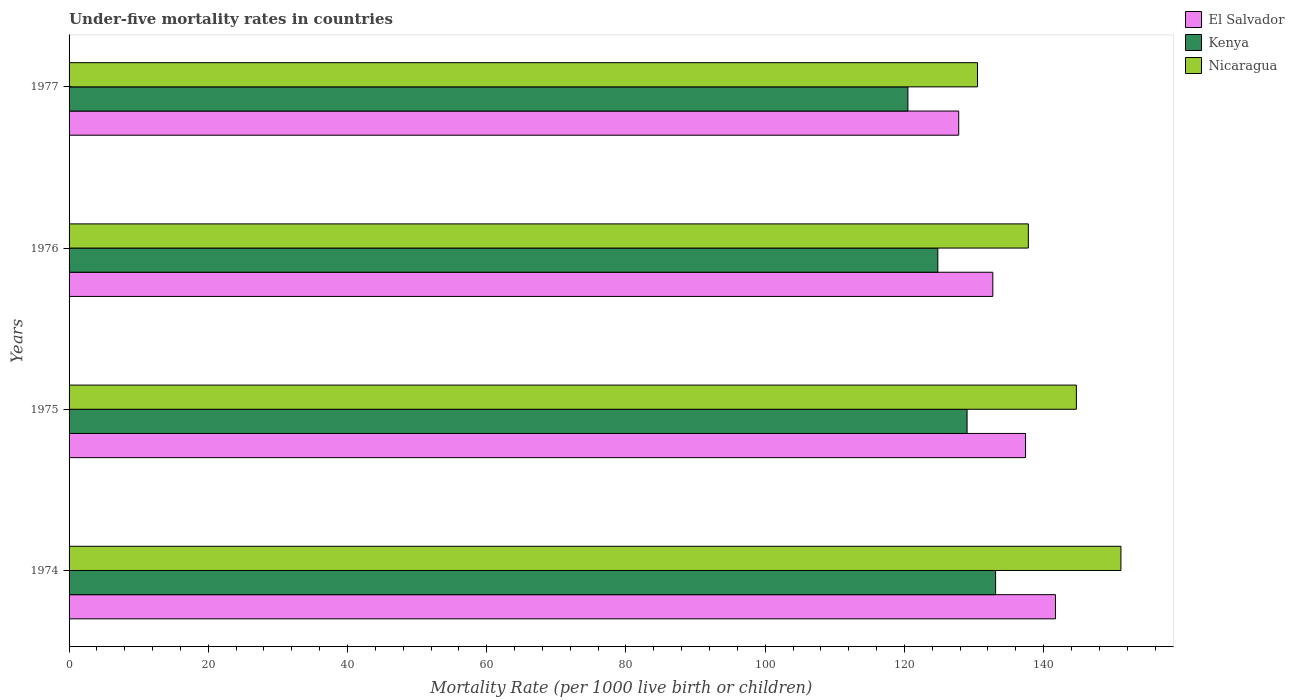How many different coloured bars are there?
Provide a short and direct response. 3. How many groups of bars are there?
Offer a terse response. 4. How many bars are there on the 3rd tick from the top?
Offer a terse response. 3. What is the label of the 2nd group of bars from the top?
Ensure brevity in your answer.  1976. What is the under-five mortality rate in El Salvador in 1977?
Give a very brief answer. 127.8. Across all years, what is the maximum under-five mortality rate in Kenya?
Ensure brevity in your answer.  133.1. Across all years, what is the minimum under-five mortality rate in Kenya?
Your answer should be compact. 120.5. In which year was the under-five mortality rate in Kenya maximum?
Make the answer very short. 1974. What is the total under-five mortality rate in Nicaragua in the graph?
Ensure brevity in your answer.  564.1. What is the difference between the under-five mortality rate in Nicaragua in 1975 and that in 1976?
Give a very brief answer. 6.9. What is the difference between the under-five mortality rate in Kenya in 1975 and the under-five mortality rate in Nicaragua in 1976?
Make the answer very short. -8.8. What is the average under-five mortality rate in Nicaragua per year?
Your answer should be compact. 141.02. In the year 1974, what is the difference between the under-five mortality rate in El Salvador and under-five mortality rate in Kenya?
Your response must be concise. 8.6. What is the ratio of the under-five mortality rate in El Salvador in 1976 to that in 1977?
Your response must be concise. 1.04. Is the under-five mortality rate in Kenya in 1975 less than that in 1977?
Give a very brief answer. No. What is the difference between the highest and the second highest under-five mortality rate in Nicaragua?
Offer a very short reply. 6.4. What is the difference between the highest and the lowest under-five mortality rate in El Salvador?
Give a very brief answer. 13.9. Is the sum of the under-five mortality rate in Kenya in 1976 and 1977 greater than the maximum under-five mortality rate in El Salvador across all years?
Give a very brief answer. Yes. What does the 1st bar from the top in 1977 represents?
Provide a succinct answer. Nicaragua. What does the 1st bar from the bottom in 1975 represents?
Offer a terse response. El Salvador. Is it the case that in every year, the sum of the under-five mortality rate in El Salvador and under-five mortality rate in Nicaragua is greater than the under-five mortality rate in Kenya?
Offer a terse response. Yes. How many bars are there?
Offer a terse response. 12. How many years are there in the graph?
Ensure brevity in your answer.  4. Are the values on the major ticks of X-axis written in scientific E-notation?
Keep it short and to the point. No. Does the graph contain grids?
Offer a very short reply. No. Where does the legend appear in the graph?
Give a very brief answer. Top right. How many legend labels are there?
Keep it short and to the point. 3. What is the title of the graph?
Your response must be concise. Under-five mortality rates in countries. What is the label or title of the X-axis?
Offer a terse response. Mortality Rate (per 1000 live birth or children). What is the label or title of the Y-axis?
Provide a succinct answer. Years. What is the Mortality Rate (per 1000 live birth or children) in El Salvador in 1974?
Offer a very short reply. 141.7. What is the Mortality Rate (per 1000 live birth or children) in Kenya in 1974?
Provide a succinct answer. 133.1. What is the Mortality Rate (per 1000 live birth or children) in Nicaragua in 1974?
Offer a very short reply. 151.1. What is the Mortality Rate (per 1000 live birth or children) in El Salvador in 1975?
Your answer should be compact. 137.4. What is the Mortality Rate (per 1000 live birth or children) in Kenya in 1975?
Provide a succinct answer. 129. What is the Mortality Rate (per 1000 live birth or children) in Nicaragua in 1975?
Your answer should be very brief. 144.7. What is the Mortality Rate (per 1000 live birth or children) of El Salvador in 1976?
Your answer should be very brief. 132.7. What is the Mortality Rate (per 1000 live birth or children) in Kenya in 1976?
Offer a very short reply. 124.8. What is the Mortality Rate (per 1000 live birth or children) in Nicaragua in 1976?
Your answer should be very brief. 137.8. What is the Mortality Rate (per 1000 live birth or children) of El Salvador in 1977?
Give a very brief answer. 127.8. What is the Mortality Rate (per 1000 live birth or children) in Kenya in 1977?
Provide a short and direct response. 120.5. What is the Mortality Rate (per 1000 live birth or children) of Nicaragua in 1977?
Ensure brevity in your answer.  130.5. Across all years, what is the maximum Mortality Rate (per 1000 live birth or children) of El Salvador?
Your response must be concise. 141.7. Across all years, what is the maximum Mortality Rate (per 1000 live birth or children) in Kenya?
Offer a very short reply. 133.1. Across all years, what is the maximum Mortality Rate (per 1000 live birth or children) of Nicaragua?
Provide a succinct answer. 151.1. Across all years, what is the minimum Mortality Rate (per 1000 live birth or children) in El Salvador?
Your answer should be compact. 127.8. Across all years, what is the minimum Mortality Rate (per 1000 live birth or children) of Kenya?
Your answer should be very brief. 120.5. Across all years, what is the minimum Mortality Rate (per 1000 live birth or children) in Nicaragua?
Ensure brevity in your answer.  130.5. What is the total Mortality Rate (per 1000 live birth or children) in El Salvador in the graph?
Provide a short and direct response. 539.6. What is the total Mortality Rate (per 1000 live birth or children) in Kenya in the graph?
Your answer should be very brief. 507.4. What is the total Mortality Rate (per 1000 live birth or children) of Nicaragua in the graph?
Your answer should be very brief. 564.1. What is the difference between the Mortality Rate (per 1000 live birth or children) of Kenya in 1974 and that in 1975?
Offer a terse response. 4.1. What is the difference between the Mortality Rate (per 1000 live birth or children) of El Salvador in 1974 and that in 1976?
Offer a very short reply. 9. What is the difference between the Mortality Rate (per 1000 live birth or children) of Kenya in 1974 and that in 1976?
Ensure brevity in your answer.  8.3. What is the difference between the Mortality Rate (per 1000 live birth or children) of Nicaragua in 1974 and that in 1976?
Provide a succinct answer. 13.3. What is the difference between the Mortality Rate (per 1000 live birth or children) of Nicaragua in 1974 and that in 1977?
Offer a very short reply. 20.6. What is the difference between the Mortality Rate (per 1000 live birth or children) of Nicaragua in 1975 and that in 1976?
Offer a terse response. 6.9. What is the difference between the Mortality Rate (per 1000 live birth or children) in El Salvador in 1975 and that in 1977?
Offer a terse response. 9.6. What is the difference between the Mortality Rate (per 1000 live birth or children) in Kenya in 1975 and that in 1977?
Offer a very short reply. 8.5. What is the difference between the Mortality Rate (per 1000 live birth or children) in Nicaragua in 1975 and that in 1977?
Give a very brief answer. 14.2. What is the difference between the Mortality Rate (per 1000 live birth or children) of El Salvador in 1976 and that in 1977?
Ensure brevity in your answer.  4.9. What is the difference between the Mortality Rate (per 1000 live birth or children) in Kenya in 1976 and that in 1977?
Your answer should be very brief. 4.3. What is the difference between the Mortality Rate (per 1000 live birth or children) in El Salvador in 1974 and the Mortality Rate (per 1000 live birth or children) in Kenya in 1975?
Ensure brevity in your answer.  12.7. What is the difference between the Mortality Rate (per 1000 live birth or children) of El Salvador in 1974 and the Mortality Rate (per 1000 live birth or children) of Kenya in 1976?
Ensure brevity in your answer.  16.9. What is the difference between the Mortality Rate (per 1000 live birth or children) in El Salvador in 1974 and the Mortality Rate (per 1000 live birth or children) in Nicaragua in 1976?
Your response must be concise. 3.9. What is the difference between the Mortality Rate (per 1000 live birth or children) in El Salvador in 1974 and the Mortality Rate (per 1000 live birth or children) in Kenya in 1977?
Give a very brief answer. 21.2. What is the difference between the Mortality Rate (per 1000 live birth or children) of El Salvador in 1974 and the Mortality Rate (per 1000 live birth or children) of Nicaragua in 1977?
Your answer should be compact. 11.2. What is the difference between the Mortality Rate (per 1000 live birth or children) in Kenya in 1974 and the Mortality Rate (per 1000 live birth or children) in Nicaragua in 1977?
Provide a short and direct response. 2.6. What is the difference between the Mortality Rate (per 1000 live birth or children) of El Salvador in 1975 and the Mortality Rate (per 1000 live birth or children) of Kenya in 1976?
Keep it short and to the point. 12.6. What is the difference between the Mortality Rate (per 1000 live birth or children) of Kenya in 1975 and the Mortality Rate (per 1000 live birth or children) of Nicaragua in 1976?
Offer a terse response. -8.8. What is the difference between the Mortality Rate (per 1000 live birth or children) of El Salvador in 1975 and the Mortality Rate (per 1000 live birth or children) of Kenya in 1977?
Offer a very short reply. 16.9. What is the difference between the Mortality Rate (per 1000 live birth or children) of El Salvador in 1975 and the Mortality Rate (per 1000 live birth or children) of Nicaragua in 1977?
Your response must be concise. 6.9. What is the difference between the Mortality Rate (per 1000 live birth or children) of Kenya in 1975 and the Mortality Rate (per 1000 live birth or children) of Nicaragua in 1977?
Ensure brevity in your answer.  -1.5. What is the difference between the Mortality Rate (per 1000 live birth or children) of El Salvador in 1976 and the Mortality Rate (per 1000 live birth or children) of Kenya in 1977?
Your answer should be compact. 12.2. What is the difference between the Mortality Rate (per 1000 live birth or children) of Kenya in 1976 and the Mortality Rate (per 1000 live birth or children) of Nicaragua in 1977?
Offer a very short reply. -5.7. What is the average Mortality Rate (per 1000 live birth or children) in El Salvador per year?
Make the answer very short. 134.9. What is the average Mortality Rate (per 1000 live birth or children) in Kenya per year?
Offer a terse response. 126.85. What is the average Mortality Rate (per 1000 live birth or children) of Nicaragua per year?
Make the answer very short. 141.03. In the year 1974, what is the difference between the Mortality Rate (per 1000 live birth or children) in Kenya and Mortality Rate (per 1000 live birth or children) in Nicaragua?
Give a very brief answer. -18. In the year 1975, what is the difference between the Mortality Rate (per 1000 live birth or children) in El Salvador and Mortality Rate (per 1000 live birth or children) in Nicaragua?
Provide a short and direct response. -7.3. In the year 1975, what is the difference between the Mortality Rate (per 1000 live birth or children) of Kenya and Mortality Rate (per 1000 live birth or children) of Nicaragua?
Offer a very short reply. -15.7. In the year 1976, what is the difference between the Mortality Rate (per 1000 live birth or children) in Kenya and Mortality Rate (per 1000 live birth or children) in Nicaragua?
Make the answer very short. -13. What is the ratio of the Mortality Rate (per 1000 live birth or children) of El Salvador in 1974 to that in 1975?
Keep it short and to the point. 1.03. What is the ratio of the Mortality Rate (per 1000 live birth or children) of Kenya in 1974 to that in 1975?
Provide a succinct answer. 1.03. What is the ratio of the Mortality Rate (per 1000 live birth or children) in Nicaragua in 1974 to that in 1975?
Provide a short and direct response. 1.04. What is the ratio of the Mortality Rate (per 1000 live birth or children) of El Salvador in 1974 to that in 1976?
Provide a succinct answer. 1.07. What is the ratio of the Mortality Rate (per 1000 live birth or children) in Kenya in 1974 to that in 1976?
Make the answer very short. 1.07. What is the ratio of the Mortality Rate (per 1000 live birth or children) in Nicaragua in 1974 to that in 1976?
Give a very brief answer. 1.1. What is the ratio of the Mortality Rate (per 1000 live birth or children) of El Salvador in 1974 to that in 1977?
Offer a terse response. 1.11. What is the ratio of the Mortality Rate (per 1000 live birth or children) of Kenya in 1974 to that in 1977?
Your answer should be very brief. 1.1. What is the ratio of the Mortality Rate (per 1000 live birth or children) in Nicaragua in 1974 to that in 1977?
Provide a short and direct response. 1.16. What is the ratio of the Mortality Rate (per 1000 live birth or children) of El Salvador in 1975 to that in 1976?
Provide a short and direct response. 1.04. What is the ratio of the Mortality Rate (per 1000 live birth or children) of Kenya in 1975 to that in 1976?
Your response must be concise. 1.03. What is the ratio of the Mortality Rate (per 1000 live birth or children) of Nicaragua in 1975 to that in 1976?
Your answer should be compact. 1.05. What is the ratio of the Mortality Rate (per 1000 live birth or children) in El Salvador in 1975 to that in 1977?
Offer a very short reply. 1.08. What is the ratio of the Mortality Rate (per 1000 live birth or children) in Kenya in 1975 to that in 1977?
Give a very brief answer. 1.07. What is the ratio of the Mortality Rate (per 1000 live birth or children) in Nicaragua in 1975 to that in 1977?
Your answer should be compact. 1.11. What is the ratio of the Mortality Rate (per 1000 live birth or children) of El Salvador in 1976 to that in 1977?
Offer a terse response. 1.04. What is the ratio of the Mortality Rate (per 1000 live birth or children) of Kenya in 1976 to that in 1977?
Give a very brief answer. 1.04. What is the ratio of the Mortality Rate (per 1000 live birth or children) of Nicaragua in 1976 to that in 1977?
Keep it short and to the point. 1.06. What is the difference between the highest and the second highest Mortality Rate (per 1000 live birth or children) in Kenya?
Provide a short and direct response. 4.1. What is the difference between the highest and the second highest Mortality Rate (per 1000 live birth or children) of Nicaragua?
Keep it short and to the point. 6.4. What is the difference between the highest and the lowest Mortality Rate (per 1000 live birth or children) of Nicaragua?
Provide a succinct answer. 20.6. 